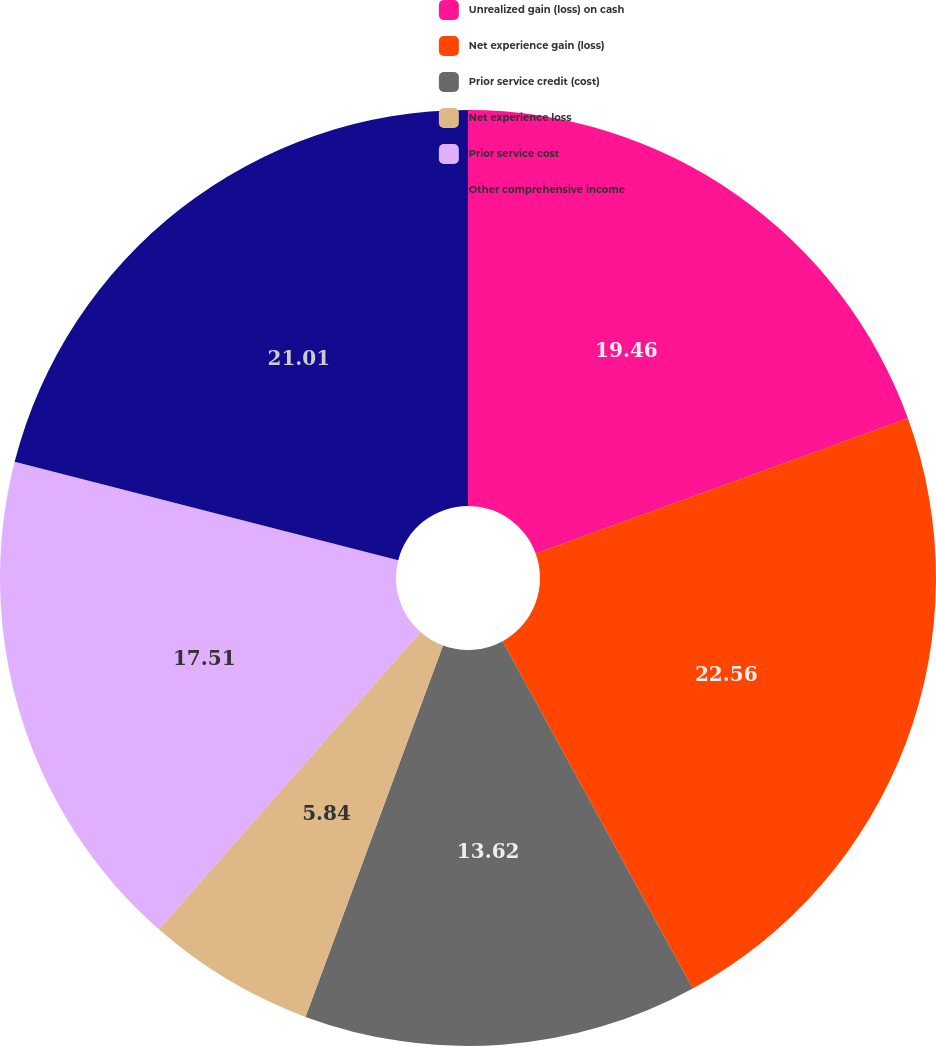Convert chart to OTSL. <chart><loc_0><loc_0><loc_500><loc_500><pie_chart><fcel>Unrealized gain (loss) on cash<fcel>Net experience gain (loss)<fcel>Prior service credit (cost)<fcel>Net experience loss<fcel>Prior service cost<fcel>Other comprehensive income<nl><fcel>19.46%<fcel>22.57%<fcel>13.62%<fcel>5.84%<fcel>17.51%<fcel>21.01%<nl></chart> 